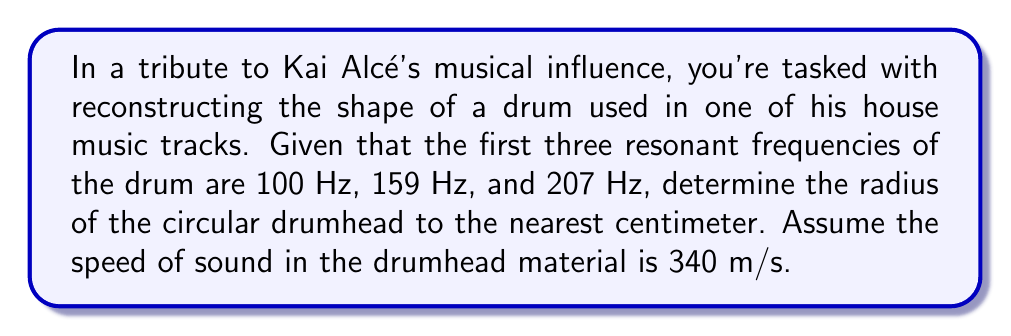Could you help me with this problem? To solve this problem, we'll use the formula for the resonant frequencies of a circular membrane:

$$f_n = \frac{\alpha_{mn}c}{2\pi r}$$

Where:
$f_n$ is the nth resonant frequency
$\alpha_{mn}$ are the zeros of the Bessel function of the first kind
$c$ is the speed of sound in the material
$r$ is the radius of the drum

For a circular drum, the first three $\alpha_{mn}$ values are:
$\alpha_{01} \approx 2.4048$
$\alpha_{11} \approx 3.8317$
$\alpha_{21} \approx 5.1356$

Step 1: Set up three equations using the given frequencies:

$$100 = \frac{2.4048 \cdot 340}{2\pi r}$$
$$159 = \frac{3.8317 \cdot 340}{2\pi r}$$
$$207 = \frac{5.1356 \cdot 340}{2\pi r}$$

Step 2: Rearrange each equation to solve for r:

$$r = \frac{2.4048 \cdot 340}{2\pi \cdot 100}$$
$$r = \frac{3.8317 \cdot 340}{2\pi \cdot 159}$$
$$r = \frac{5.1356 \cdot 340}{2\pi \cdot 207}$$

Step 3: Calculate r for each equation:

$$r_1 = 0.1298 \text{ m}$$
$$r_2 = 0.1297 \text{ m}$$
$$r_3 = 0.1329 \text{ m}$$

Step 4: Take the average of these three values:

$$r_{avg} = \frac{0.1298 + 0.1297 + 0.1329}{3} = 0.1308 \text{ m}$$

Step 5: Convert to centimeters and round to the nearest whole number:

$$r_{cm} = 0.1308 \cdot 100 \approx 13 \text{ cm}$$
Answer: 13 cm 